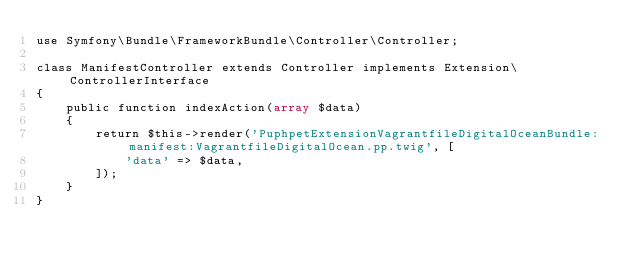Convert code to text. <code><loc_0><loc_0><loc_500><loc_500><_PHP_>use Symfony\Bundle\FrameworkBundle\Controller\Controller;

class ManifestController extends Controller implements Extension\ControllerInterface
{
    public function indexAction(array $data)
    {
        return $this->render('PuphpetExtensionVagrantfileDigitalOceanBundle:manifest:VagrantfileDigitalOcean.pp.twig', [
            'data' => $data,
        ]);
    }
}
</code> 